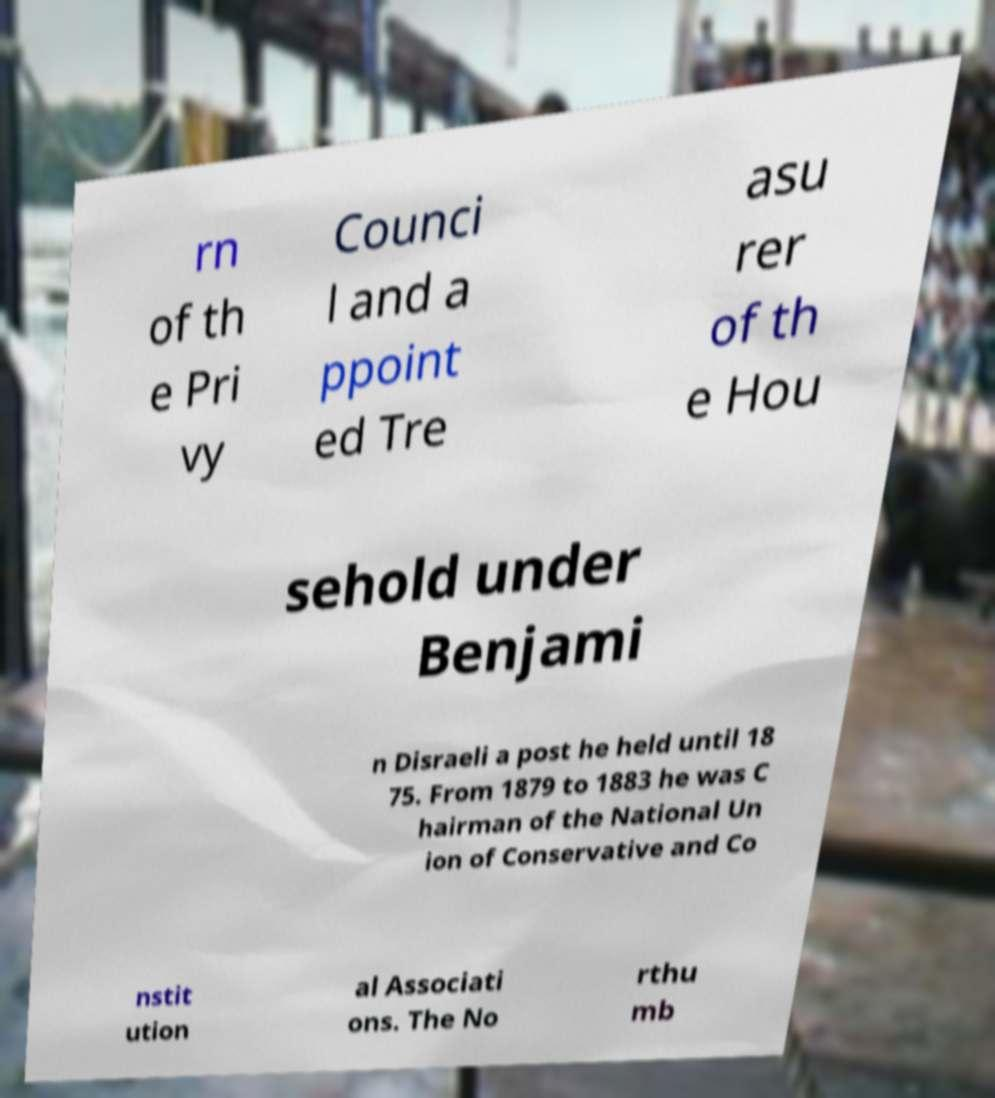What messages or text are displayed in this image? I need them in a readable, typed format. rn of th e Pri vy Counci l and a ppoint ed Tre asu rer of th e Hou sehold under Benjami n Disraeli a post he held until 18 75. From 1879 to 1883 he was C hairman of the National Un ion of Conservative and Co nstit ution al Associati ons. The No rthu mb 